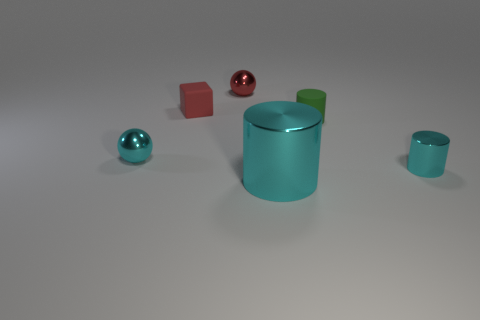What size is the thing that is the same color as the small block?
Give a very brief answer. Small. There is a cyan shiny thing that is the same shape as the small red metal thing; what size is it?
Give a very brief answer. Small. Are there any other things that have the same size as the red rubber thing?
Your answer should be compact. Yes. What material is the ball to the left of the sphere behind the ball that is in front of the tiny green matte cylinder?
Give a very brief answer. Metal. Are there more big cyan cylinders that are on the left side of the big metal thing than cyan metallic things that are right of the red matte thing?
Your answer should be compact. No. Do the red block and the red metal thing have the same size?
Offer a terse response. Yes. What color is the other metal object that is the same shape as the small red shiny object?
Keep it short and to the point. Cyan. What number of other blocks are the same color as the rubber block?
Give a very brief answer. 0. Is the number of tiny red spheres that are in front of the big cyan thing greater than the number of brown things?
Provide a short and direct response. No. There is a tiny object that is in front of the sphere that is in front of the red shiny object; what color is it?
Keep it short and to the point. Cyan. 